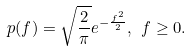<formula> <loc_0><loc_0><loc_500><loc_500>p ( f ) = \sqrt { \frac { 2 } { \pi } } e ^ { - \frac { f ^ { 2 } } { 2 } } , \ f \geq 0 .</formula> 